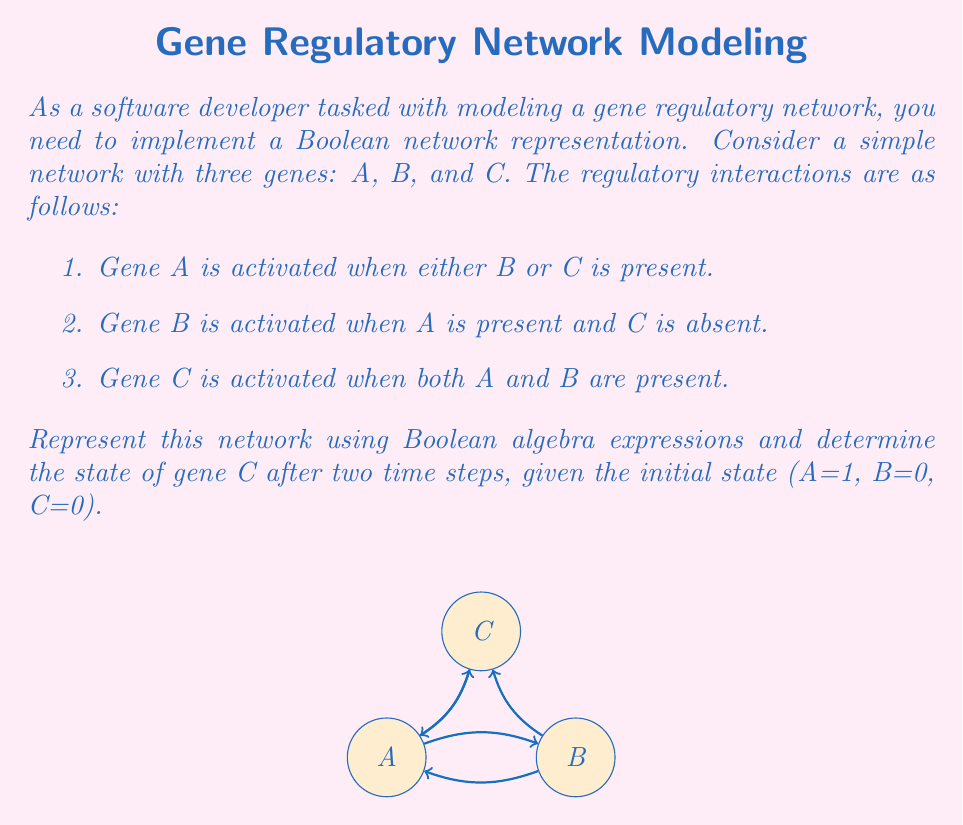What is the answer to this math problem? Let's approach this step-by-step:

1. First, we need to represent the regulatory interactions using Boolean algebra:

   A = B OR C
   B = A AND (NOT C)
   C = A AND B

   In Boolean algebra notation:
   $$A_{t+1} = B_t \lor C_t$$
   $$B_{t+1} = A_t \land \neg C_t$$
   $$C_{t+1} = A_t \land B_t$$

   Where $t$ represents the current time step and $t+1$ the next time step.

2. Given the initial state (A=1, B=0, C=0), let's calculate the state after one time step:

   $$A_1 = B_0 \lor C_0 = 0 \lor 0 = 0$$
   $$B_1 = A_0 \land \neg C_0 = 1 \land 1 = 1$$
   $$C_1 = A_0 \land B_0 = 1 \land 0 = 0$$

   So after one time step, the state is (A=0, B=1, C=0).

3. Now let's calculate the state after two time steps:

   $$A_2 = B_1 \lor C_1 = 1 \lor 0 = 1$$
   $$B_2 = A_1 \land \neg C_1 = 0 \land 1 = 0$$
   $$C_2 = A_1 \land B_1 = 0 \land 1 = 0$$

4. Therefore, after two time steps, the state of gene C is 0.

This approach is similar to unit testing in software development, where we're testing the behavior of each component (gene) based on its inputs and the defined rules.
Answer: 0 